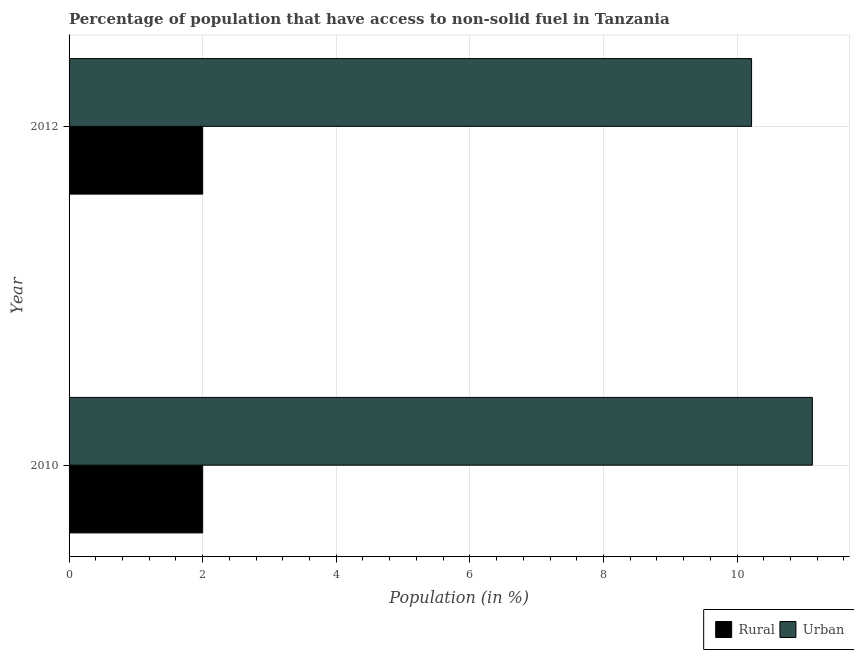How many groups of bars are there?
Provide a succinct answer. 2. Are the number of bars per tick equal to the number of legend labels?
Offer a terse response. Yes. Are the number of bars on each tick of the Y-axis equal?
Provide a short and direct response. Yes. What is the rural population in 2012?
Ensure brevity in your answer.  2. Across all years, what is the maximum rural population?
Make the answer very short. 2. Across all years, what is the minimum rural population?
Offer a very short reply. 2. In which year was the urban population minimum?
Make the answer very short. 2012. What is the total rural population in the graph?
Make the answer very short. 4. What is the difference between the urban population in 2010 and the rural population in 2012?
Keep it short and to the point. 9.13. In the year 2012, what is the difference between the rural population and urban population?
Offer a terse response. -8.22. What is the ratio of the urban population in 2010 to that in 2012?
Your response must be concise. 1.09. What does the 2nd bar from the top in 2012 represents?
Keep it short and to the point. Rural. What does the 2nd bar from the bottom in 2010 represents?
Make the answer very short. Urban. What is the difference between two consecutive major ticks on the X-axis?
Your response must be concise. 2. Does the graph contain grids?
Give a very brief answer. Yes. What is the title of the graph?
Ensure brevity in your answer.  Percentage of population that have access to non-solid fuel in Tanzania. What is the label or title of the Y-axis?
Your response must be concise. Year. What is the Population (in %) in Rural in 2010?
Make the answer very short. 2. What is the Population (in %) of Urban in 2010?
Your answer should be very brief. 11.13. What is the Population (in %) of Rural in 2012?
Make the answer very short. 2. What is the Population (in %) of Urban in 2012?
Give a very brief answer. 10.22. Across all years, what is the maximum Population (in %) in Rural?
Provide a succinct answer. 2. Across all years, what is the maximum Population (in %) in Urban?
Your answer should be compact. 11.13. Across all years, what is the minimum Population (in %) of Rural?
Ensure brevity in your answer.  2. Across all years, what is the minimum Population (in %) in Urban?
Give a very brief answer. 10.22. What is the total Population (in %) of Rural in the graph?
Provide a short and direct response. 4. What is the total Population (in %) in Urban in the graph?
Make the answer very short. 21.34. What is the difference between the Population (in %) of Rural in 2010 and that in 2012?
Offer a terse response. 0. What is the difference between the Population (in %) in Urban in 2010 and that in 2012?
Offer a terse response. 0.91. What is the difference between the Population (in %) in Rural in 2010 and the Population (in %) in Urban in 2012?
Give a very brief answer. -8.22. What is the average Population (in %) of Urban per year?
Keep it short and to the point. 10.67. In the year 2010, what is the difference between the Population (in %) of Rural and Population (in %) of Urban?
Ensure brevity in your answer.  -9.13. In the year 2012, what is the difference between the Population (in %) in Rural and Population (in %) in Urban?
Give a very brief answer. -8.22. What is the ratio of the Population (in %) in Urban in 2010 to that in 2012?
Keep it short and to the point. 1.09. What is the difference between the highest and the second highest Population (in %) in Rural?
Make the answer very short. 0. What is the difference between the highest and the second highest Population (in %) in Urban?
Provide a short and direct response. 0.91. What is the difference between the highest and the lowest Population (in %) of Rural?
Offer a terse response. 0. What is the difference between the highest and the lowest Population (in %) in Urban?
Your answer should be very brief. 0.91. 